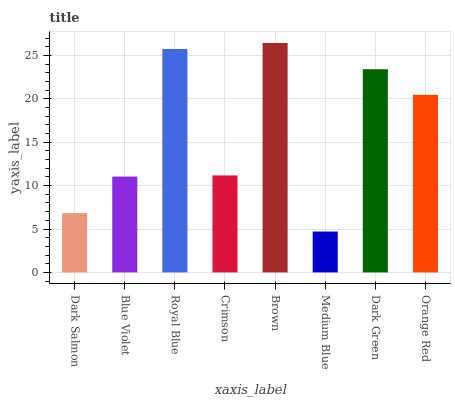Is Medium Blue the minimum?
Answer yes or no. Yes. Is Brown the maximum?
Answer yes or no. Yes. Is Blue Violet the minimum?
Answer yes or no. No. Is Blue Violet the maximum?
Answer yes or no. No. Is Blue Violet greater than Dark Salmon?
Answer yes or no. Yes. Is Dark Salmon less than Blue Violet?
Answer yes or no. Yes. Is Dark Salmon greater than Blue Violet?
Answer yes or no. No. Is Blue Violet less than Dark Salmon?
Answer yes or no. No. Is Orange Red the high median?
Answer yes or no. Yes. Is Crimson the low median?
Answer yes or no. Yes. Is Royal Blue the high median?
Answer yes or no. No. Is Royal Blue the low median?
Answer yes or no. No. 